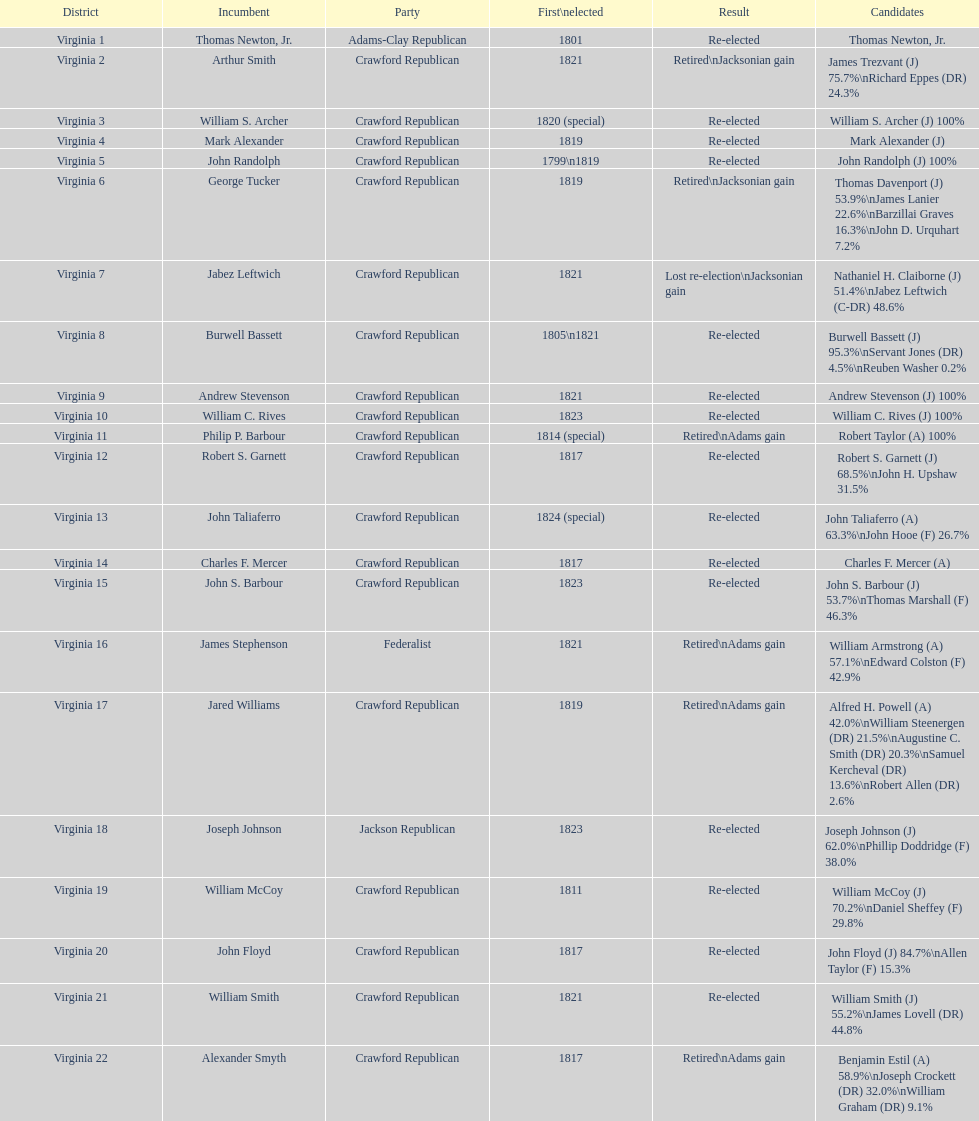In how many cases did incumbents either retire or lose their re-election bid? 7. 